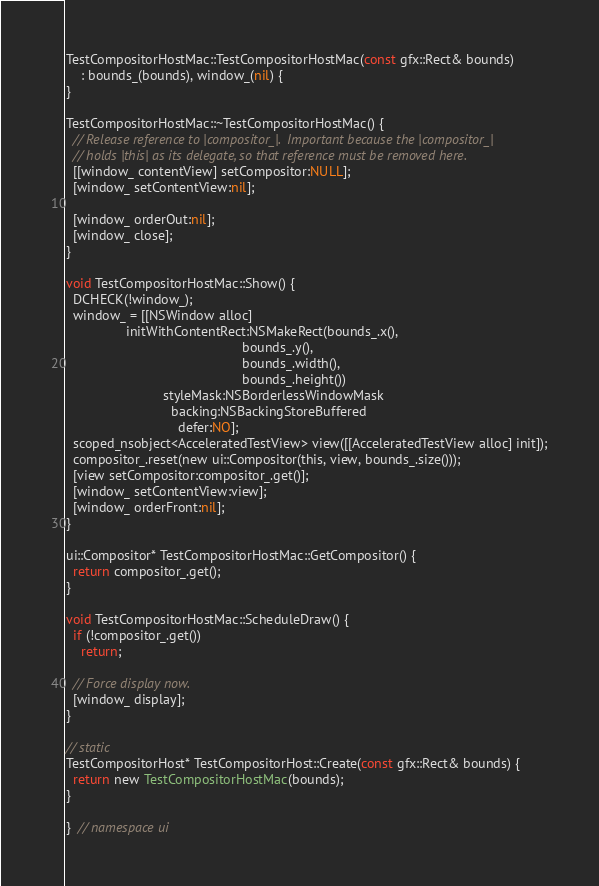Convert code to text. <code><loc_0><loc_0><loc_500><loc_500><_ObjectiveC_>
TestCompositorHostMac::TestCompositorHostMac(const gfx::Rect& bounds)
    : bounds_(bounds), window_(nil) {
}

TestCompositorHostMac::~TestCompositorHostMac() {
  // Release reference to |compositor_|.  Important because the |compositor_|
  // holds |this| as its delegate, so that reference must be removed here.
  [[window_ contentView] setCompositor:NULL];
  [window_ setContentView:nil];

  [window_ orderOut:nil];
  [window_ close];
}

void TestCompositorHostMac::Show() {
  DCHECK(!window_);
  window_ = [[NSWindow alloc]
                initWithContentRect:NSMakeRect(bounds_.x(),
                                               bounds_.y(),
                                               bounds_.width(),
                                               bounds_.height())
                          styleMask:NSBorderlessWindowMask
                            backing:NSBackingStoreBuffered
                              defer:NO];
  scoped_nsobject<AcceleratedTestView> view([[AcceleratedTestView alloc] init]);
  compositor_.reset(new ui::Compositor(this, view, bounds_.size()));
  [view setCompositor:compositor_.get()];
  [window_ setContentView:view];
  [window_ orderFront:nil];
}

ui::Compositor* TestCompositorHostMac::GetCompositor() {
  return compositor_.get();
}

void TestCompositorHostMac::ScheduleDraw() {
  if (!compositor_.get())
    return;

  // Force display now.
  [window_ display];
}

// static
TestCompositorHost* TestCompositorHost::Create(const gfx::Rect& bounds) {
  return new TestCompositorHostMac(bounds);
}

}  // namespace ui
</code> 